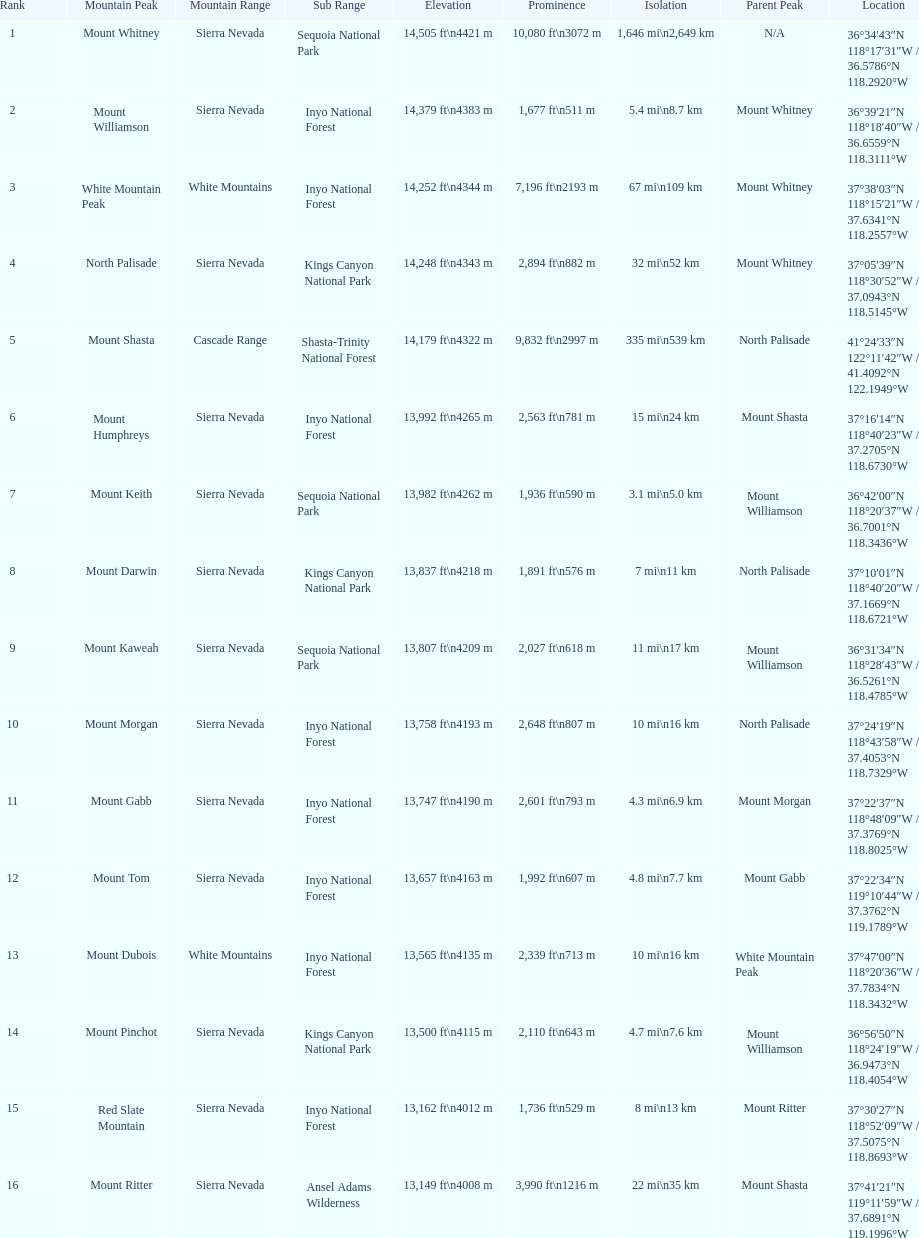Which mountain peak has the most isolation? Mount Whitney. 